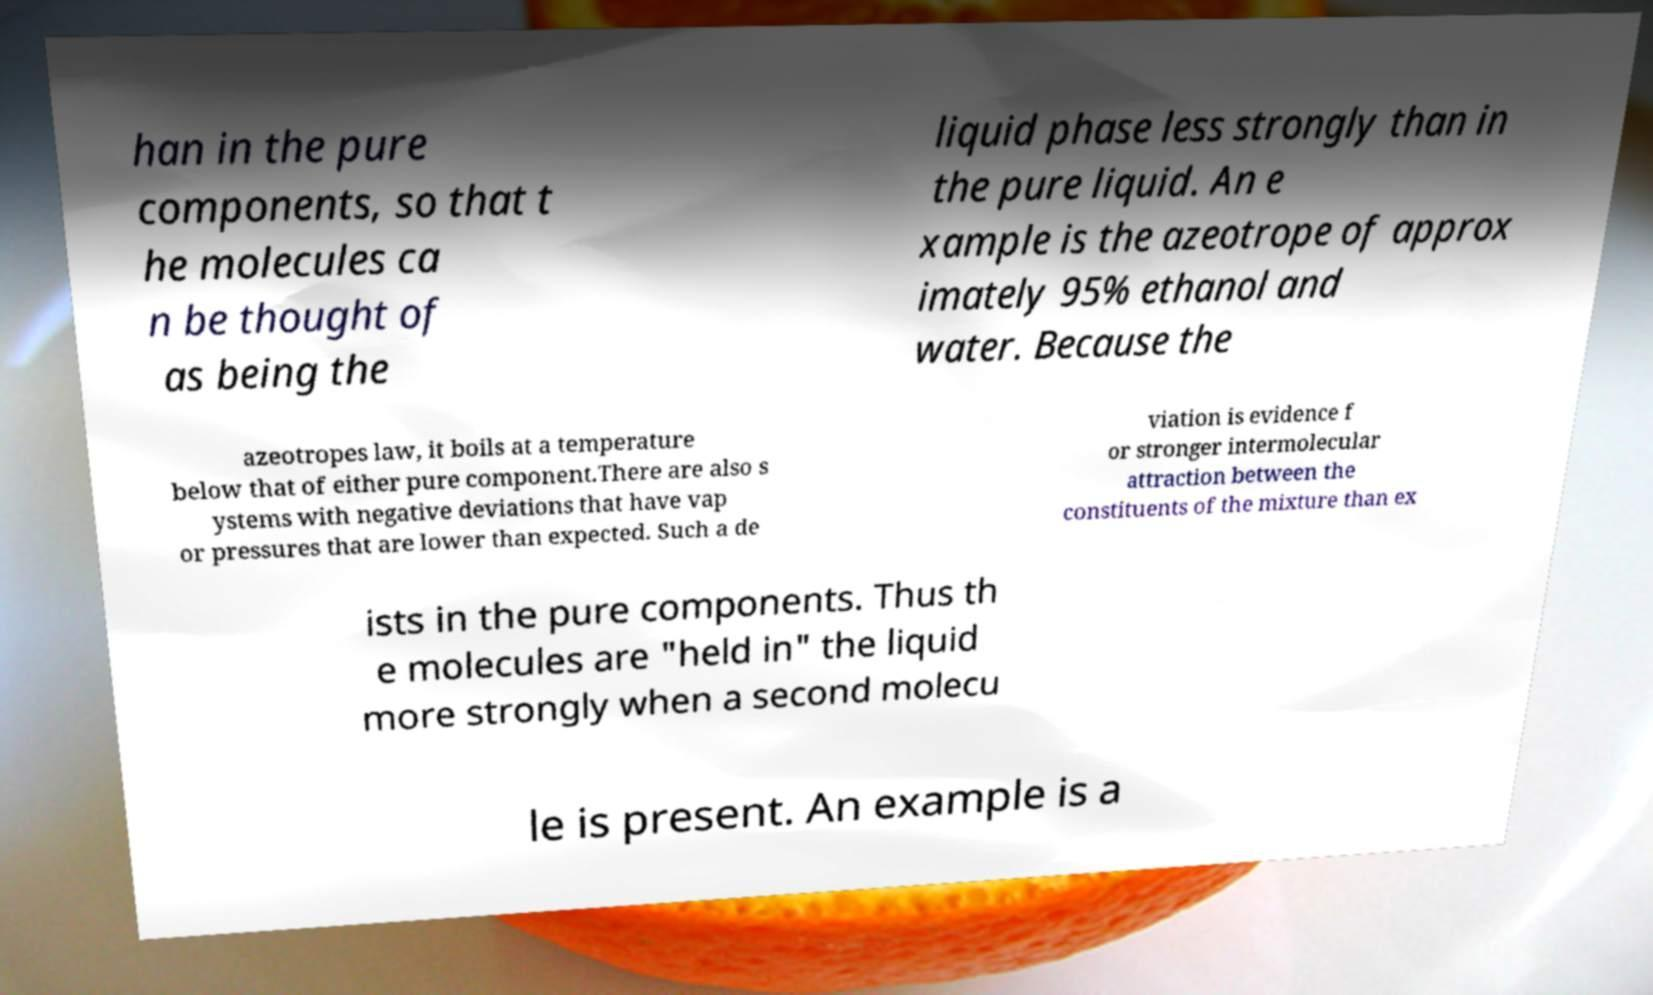What messages or text are displayed in this image? I need them in a readable, typed format. han in the pure components, so that t he molecules ca n be thought of as being the liquid phase less strongly than in the pure liquid. An e xample is the azeotrope of approx imately 95% ethanol and water. Because the azeotropes law, it boils at a temperature below that of either pure component.There are also s ystems with negative deviations that have vap or pressures that are lower than expected. Such a de viation is evidence f or stronger intermolecular attraction between the constituents of the mixture than ex ists in the pure components. Thus th e molecules are "held in" the liquid more strongly when a second molecu le is present. An example is a 